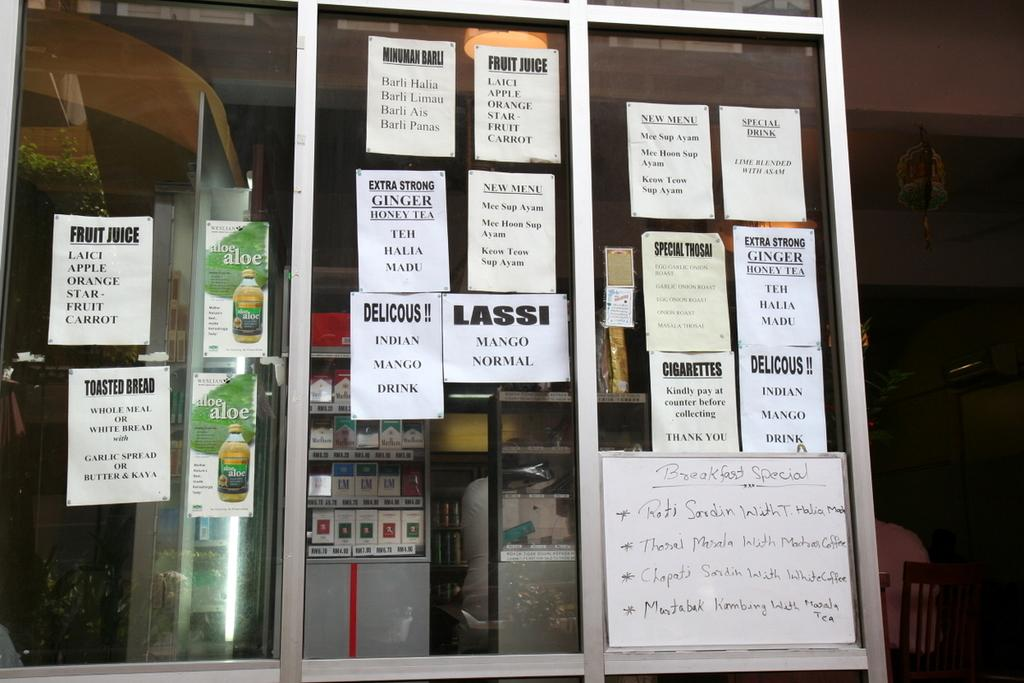<image>
Give a short and clear explanation of the subsequent image. A store window has many signs advertising such things as fruit juice and cigarettes. 